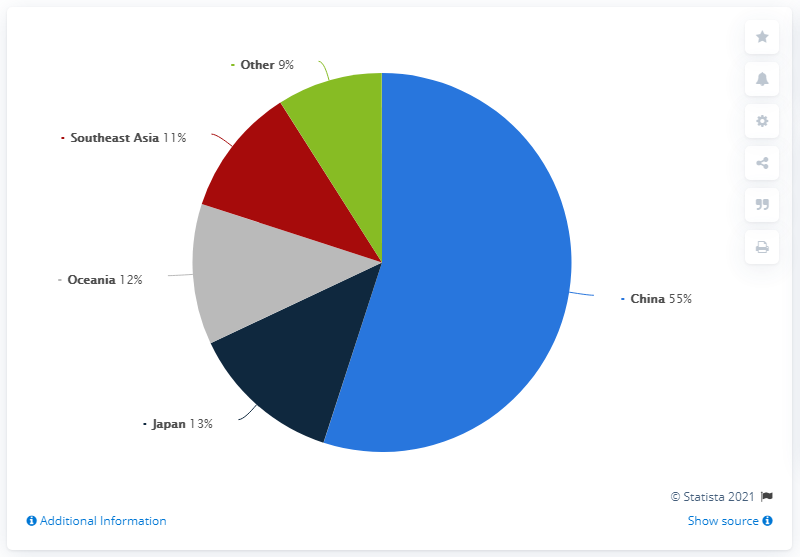Are the combined sales from countries other than China less than that of China? Yes, the combined sales from other regions such as Japan, Oceania, Southeast Asia, and Other, which total 45%, are indeed less than the sales from China alone, which account for 55% of the total. This highlights China's significant market share in comparison to other individual regions collectively. 